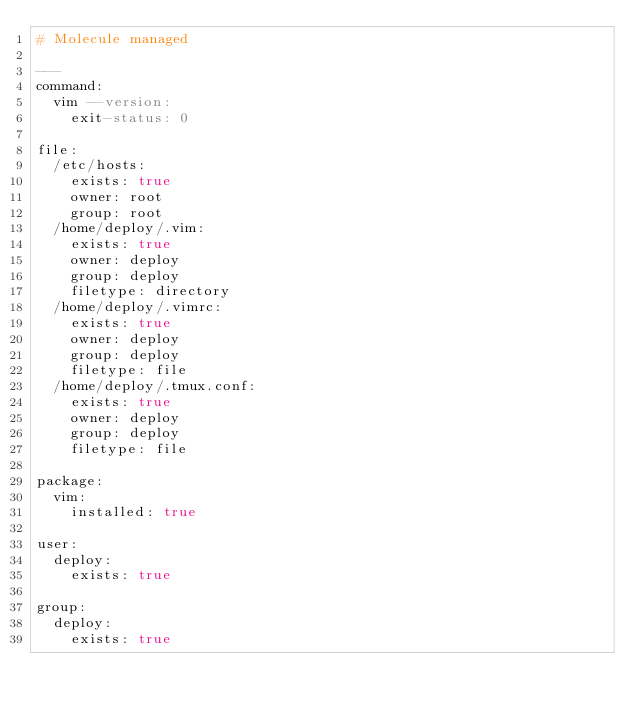Convert code to text. <code><loc_0><loc_0><loc_500><loc_500><_YAML_># Molecule managed

---
command:
  vim --version:
    exit-status: 0

file:
  /etc/hosts:
    exists: true
    owner: root
    group: root
  /home/deploy/.vim:
    exists: true
    owner: deploy
    group: deploy
    filetype: directory
  /home/deploy/.vimrc:
    exists: true
    owner: deploy
    group: deploy
    filetype: file
  /home/deploy/.tmux.conf:
    exists: true
    owner: deploy
    group: deploy
    filetype: file

package:
  vim:
    installed: true

user:
  deploy:
    exists: true

group:
  deploy:
    exists: true
</code> 